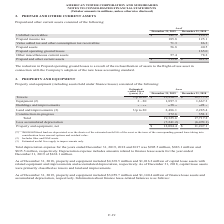According to American Tower Corporation's financial document, What was the estimated useful life of Towers in years? According to the financial document, Up to 20. The relevant text states: "Towers Up to 20 $ 13,930.7 $ 12,777.9..." Also, What was the value of Equipment in 2018? According to the financial document, 1,667.3 (in millions). The relevant text states: "Equipment (2) 2 - 20 1,897.3 1,667.3..." Also, What was the value of buildings and improvements in 2019? According to the financial document, 638.9 (in millions). The relevant text states: "Buildings and improvements 3 - 32 638.9 628.5..." Also, can you calculate: What was the change in Land and improvements between 2018 and 2019? Based on the calculation: 2,486.1-2,285.4, the result is 200.7 (in millions). This is based on the information: "Land and improvements (3) Up to 20 2,486.1 2,285.4 Land and improvements (3) Up to 20 2,486.1 2,285.4..." The key data points involved are: 2,285.4, 2,486.1. Also, can you calculate: What was the change in Construction-in-progress between 2018 and 2019? Based on the calculation: 372.6-358.1, the result is 14.5 (in millions). This is based on the information: "Construction-in-progress 372.6 358.1 Total 19,325.6 17,717.2 Construction-in-progress 372.6 358.1 Total 19,325.6 17,717.2..." The key data points involved are: 358.1, 372.6. Also, can you calculate: What was the percentage change in Property and equipment, net between 2018 and 2019? To answer this question, I need to perform calculations using the financial data. The calculation is: ($12,084.4-$11,247.1)/$11,247.1, which equals 7.44 (percentage). This is based on the information: "Property and equipment, net $ 12,084.4 $ 11,247.1 Property and equipment, net $ 12,084.4 $ 11,247.1..." The key data points involved are: 11,247.1, 12,084.4. 